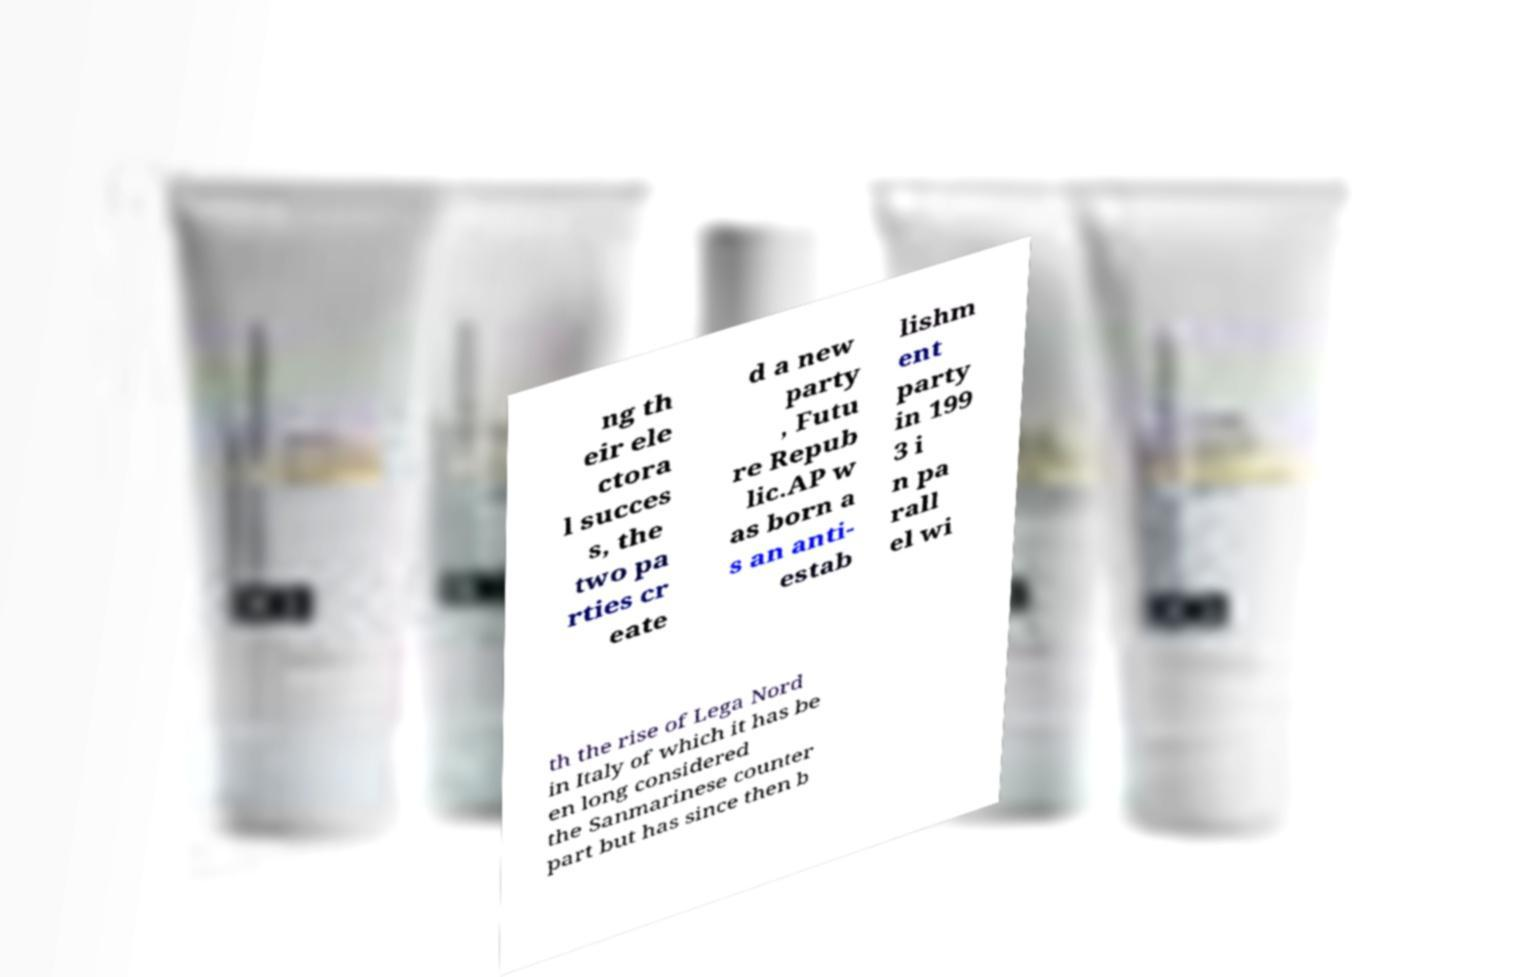Could you extract and type out the text from this image? ng th eir ele ctora l succes s, the two pa rties cr eate d a new party , Futu re Repub lic.AP w as born a s an anti- estab lishm ent party in 199 3 i n pa rall el wi th the rise of Lega Nord in Italy of which it has be en long considered the Sanmarinese counter part but has since then b 